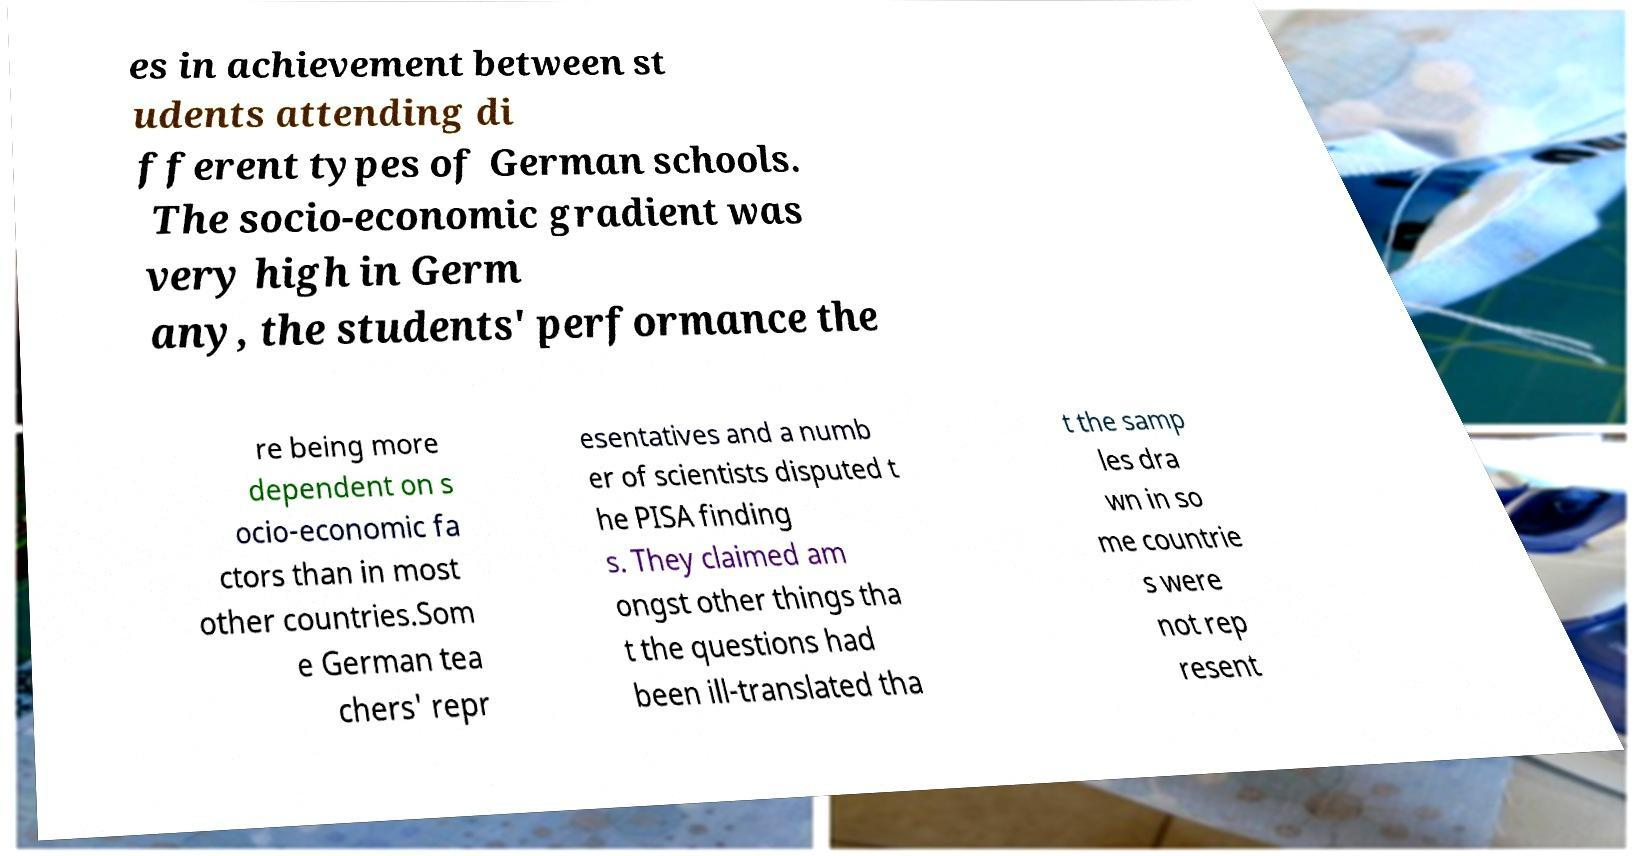There's text embedded in this image that I need extracted. Can you transcribe it verbatim? es in achievement between st udents attending di fferent types of German schools. The socio-economic gradient was very high in Germ any, the students' performance the re being more dependent on s ocio-economic fa ctors than in most other countries.Som e German tea chers' repr esentatives and a numb er of scientists disputed t he PISA finding s. They claimed am ongst other things tha t the questions had been ill-translated tha t the samp les dra wn in so me countrie s were not rep resent 